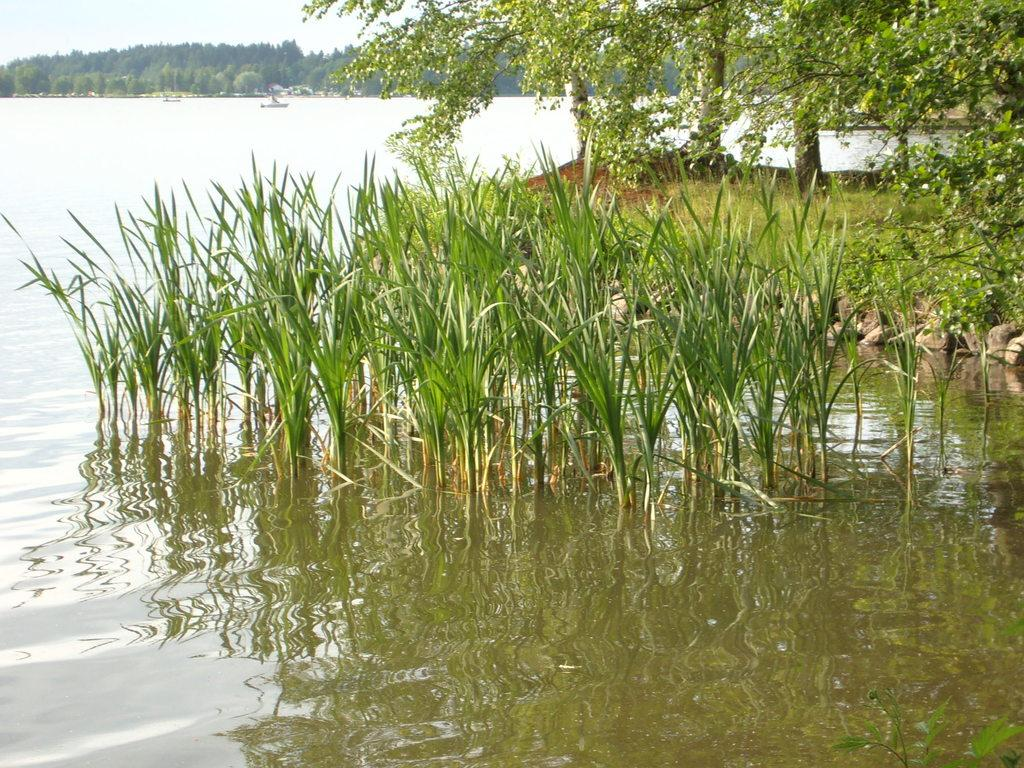What is the primary element present in the image? There is water in the image. What is floating or growing in the water? There are plants in the water. What type of vegetation can be seen in the image besides the plants in the water? There is grass visible in the image. What other large plants can be seen in the image? There are trees in the image. How many secretaries are working at the desks in the image? There are no desks or secretaries present in the image. What type of cheese do the mice in the image prefer? There are no mice present in the image. 